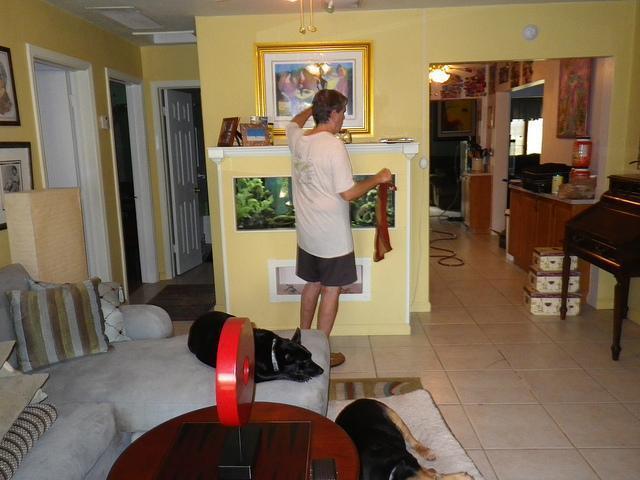How many dogs can you see?
Give a very brief answer. 2. 